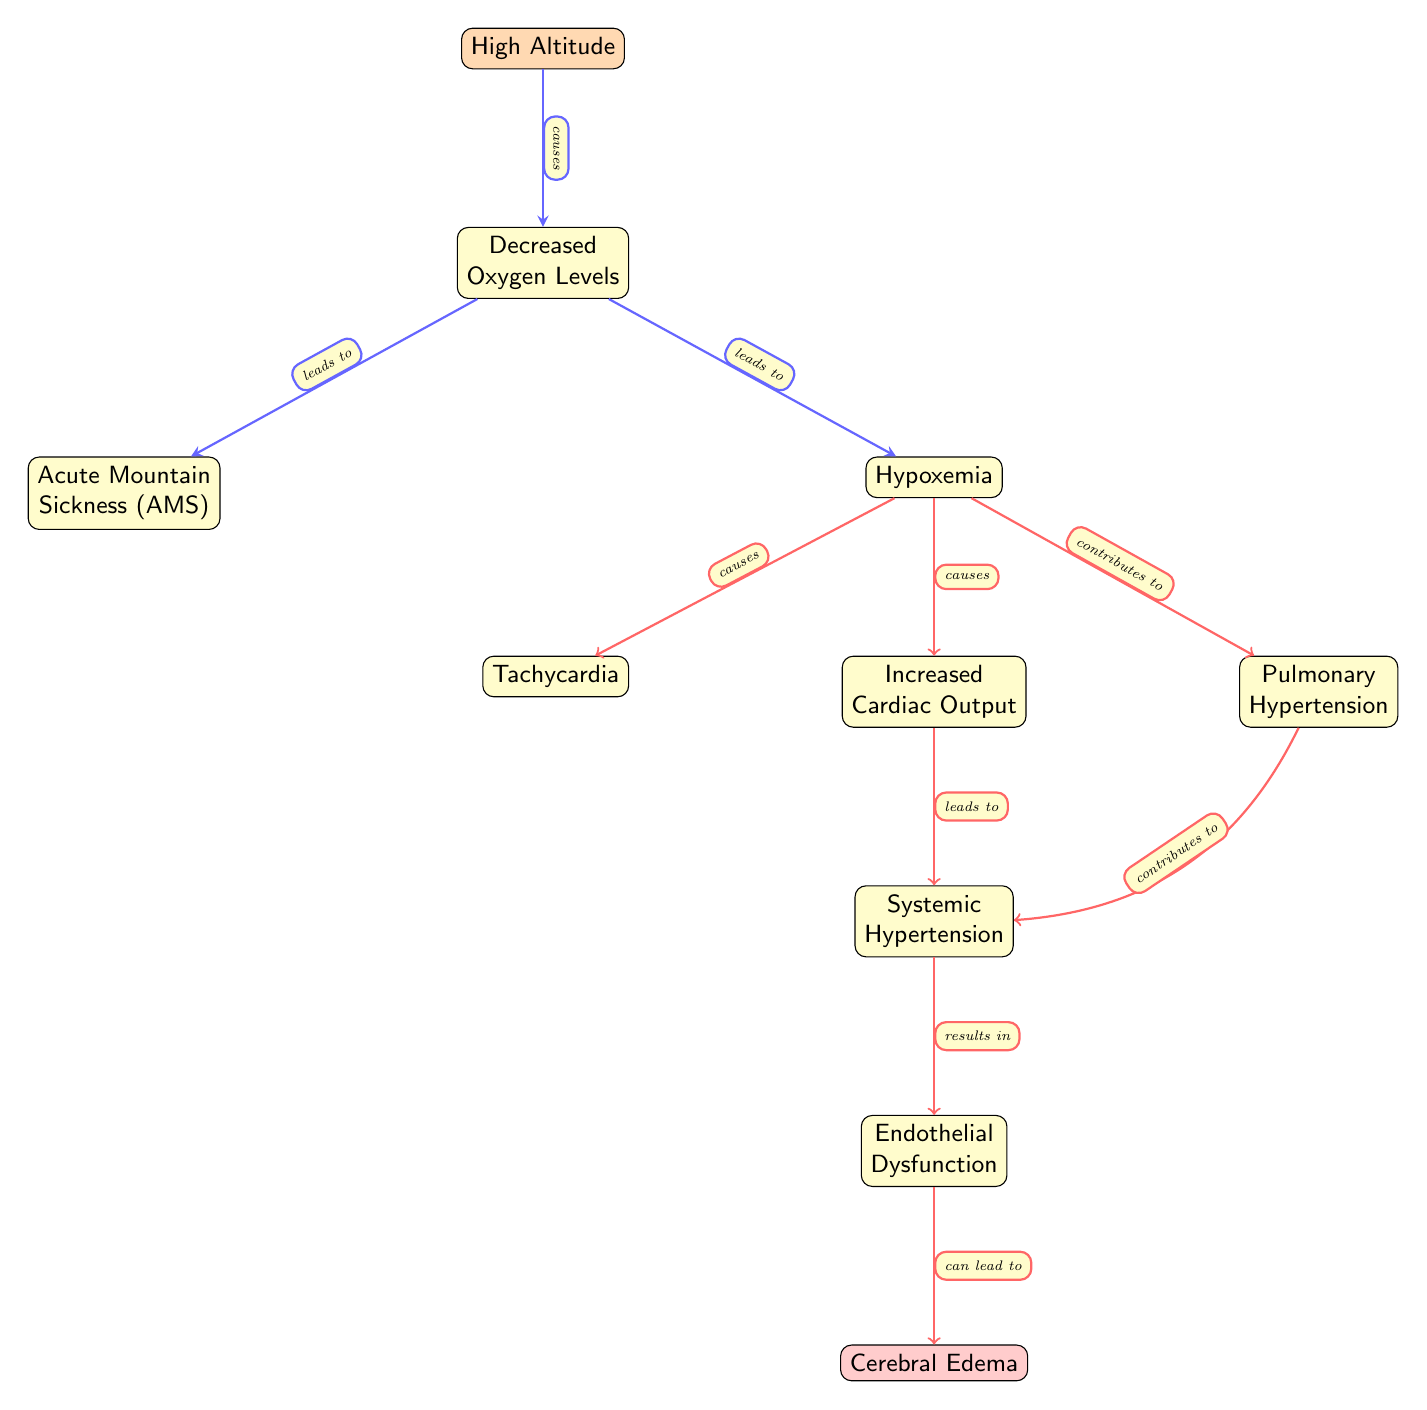What condition is caused by decreased oxygen levels at high altitude? The diagram indicates that decreased oxygen levels at high altitude lead to Acute Mountain Sickness (AMS). This is shown by the arrow labeled "leads to" from the "Decreased Oxygen Levels" node to the "Acute Mountain Sickness (AMS)" node.
Answer: Acute Mountain Sickness (AMS) Name one cardiovascular effect caused by hypoxemia. According to the diagram, hypoxemia causes tachycardia, increased cardiac output, and contributes to pulmonary hypertension. This can be deduced from the arrows that lead from the "Hypoxemia" node to the corresponding effect nodes.
Answer: Tachycardia How many nodes are there in the diagram? The diagram contains a total of ten nodes, which include conditions and physiological effects. A count of the distinct nodes displayed confirms this total.
Answer: Ten What result does increased cardiac output lead to? Following the diagram's flow, increased cardiac output leads to systemic hypertension, as denoted by the arrow that connects the "Increased Cardiac Output" node to the "Systemic Hypertension" node, labeled with "leads to."
Answer: Systemic Hypertension Which condition results from endothelial dysfunction? The diagram shows that endothelial dysfunction can lead to cerebral edema, indicated by the arrow pointing from the "Endothelial Dysfunction" node to the "Cerebral Edema" node, marked with "can lead to."
Answer: Cerebral Edema What is the direct effect of hypoxemia on the cardiovascular system shown in the diagram? The direct effects of hypoxemia on the cardiovascular system include tachycardia and increased cardiac output, as indicated by the arrows from the "Hypoxemia" node leading to these two effects.
Answer: Tachycardia and Increased Cardiac Output What condition contributes to systemic hypertension from hypoxemia? The diagram illustrates that both increased cardiac output and pulmonary hypertension contribute to systemic hypertension, as these effects branch from the hypoxemia node towards the systemic hypertension node.
Answer: Increased Cardiac Output and Pulmonary Hypertension 